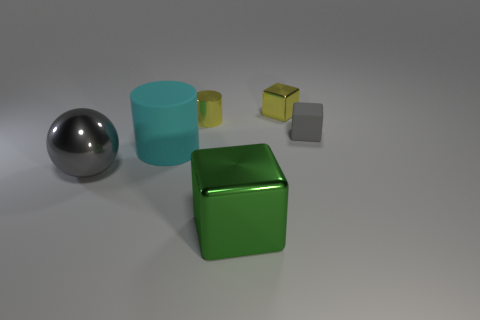Subtract all small yellow cubes. How many cubes are left? 2 Subtract all yellow cubes. How many cubes are left? 2 Subtract 1 blocks. How many blocks are left? 2 Subtract all purple cylinders. How many gray blocks are left? 1 Subtract all yellow cubes. Subtract all cyan objects. How many objects are left? 4 Add 1 yellow cubes. How many yellow cubes are left? 2 Add 6 small gray matte cubes. How many small gray matte cubes exist? 7 Add 4 large gray spheres. How many objects exist? 10 Subtract 1 green cubes. How many objects are left? 5 Subtract all cylinders. How many objects are left? 4 